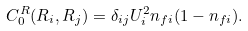Convert formula to latex. <formula><loc_0><loc_0><loc_500><loc_500>C _ { 0 } ^ { R } ( { R } _ { i } , { R } _ { j } ) = \delta _ { i j } U _ { i } ^ { 2 } n _ { f i } ( 1 - n _ { f i } ) .</formula> 